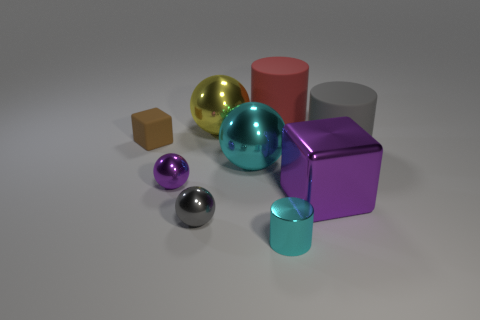What is the shape of the large shiny thing that is in front of the cyan shiny thing that is behind the small cyan cylinder?
Your answer should be very brief. Cube. Does the red object have the same material as the small ball that is behind the large metal block?
Provide a short and direct response. No. How many cyan metallic objects have the same size as the cyan metal ball?
Your response must be concise. 0. Are there fewer red matte objects that are in front of the large cyan metal thing than small purple cylinders?
Your answer should be very brief. No. How many matte objects are to the left of the big gray rubber cylinder?
Offer a very short reply. 2. There is a purple thing to the right of the large red cylinder that is behind the tiny ball that is behind the small gray metallic sphere; what size is it?
Ensure brevity in your answer.  Large. There is a gray rubber object; does it have the same shape as the object that is behind the yellow metal sphere?
Give a very brief answer. Yes. There is another purple thing that is made of the same material as the large purple thing; what size is it?
Your response must be concise. Small. Is there anything else that has the same color as the tiny matte cube?
Your answer should be very brief. No. The large sphere behind the tiny brown block in front of the large ball that is behind the brown cube is made of what material?
Provide a short and direct response. Metal. 